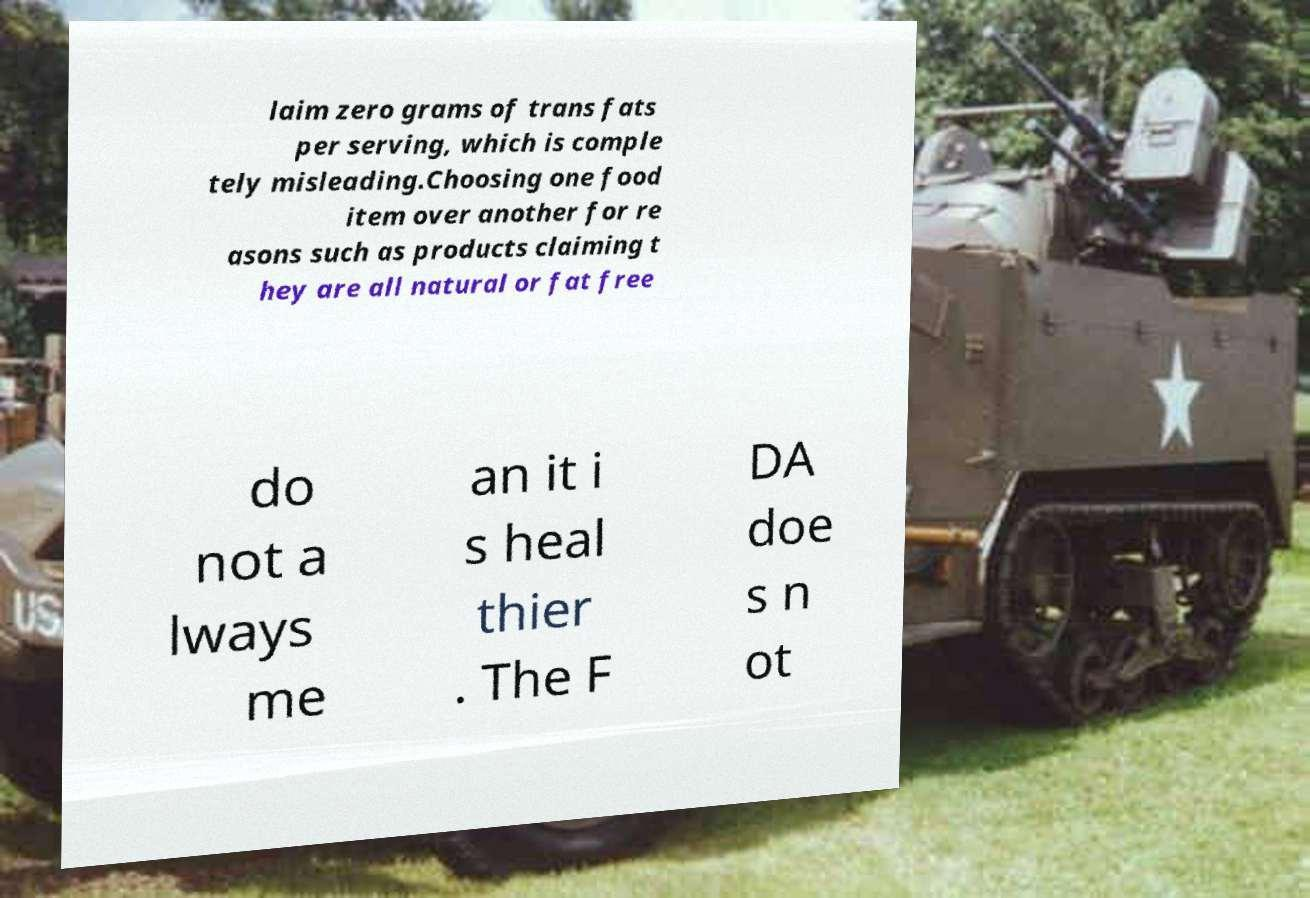For documentation purposes, I need the text within this image transcribed. Could you provide that? laim zero grams of trans fats per serving, which is comple tely misleading.Choosing one food item over another for re asons such as products claiming t hey are all natural or fat free do not a lways me an it i s heal thier . The F DA doe s n ot 